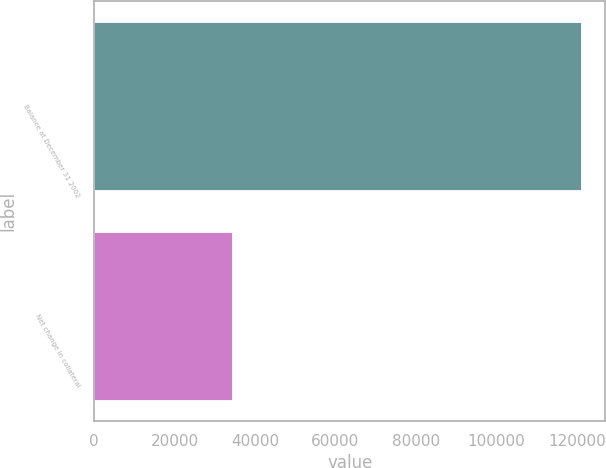Convert chart to OTSL. <chart><loc_0><loc_0><loc_500><loc_500><bar_chart><fcel>Balance at December 31 2002<fcel>Net change in collateral<nl><fcel>121068<fcel>34333<nl></chart> 